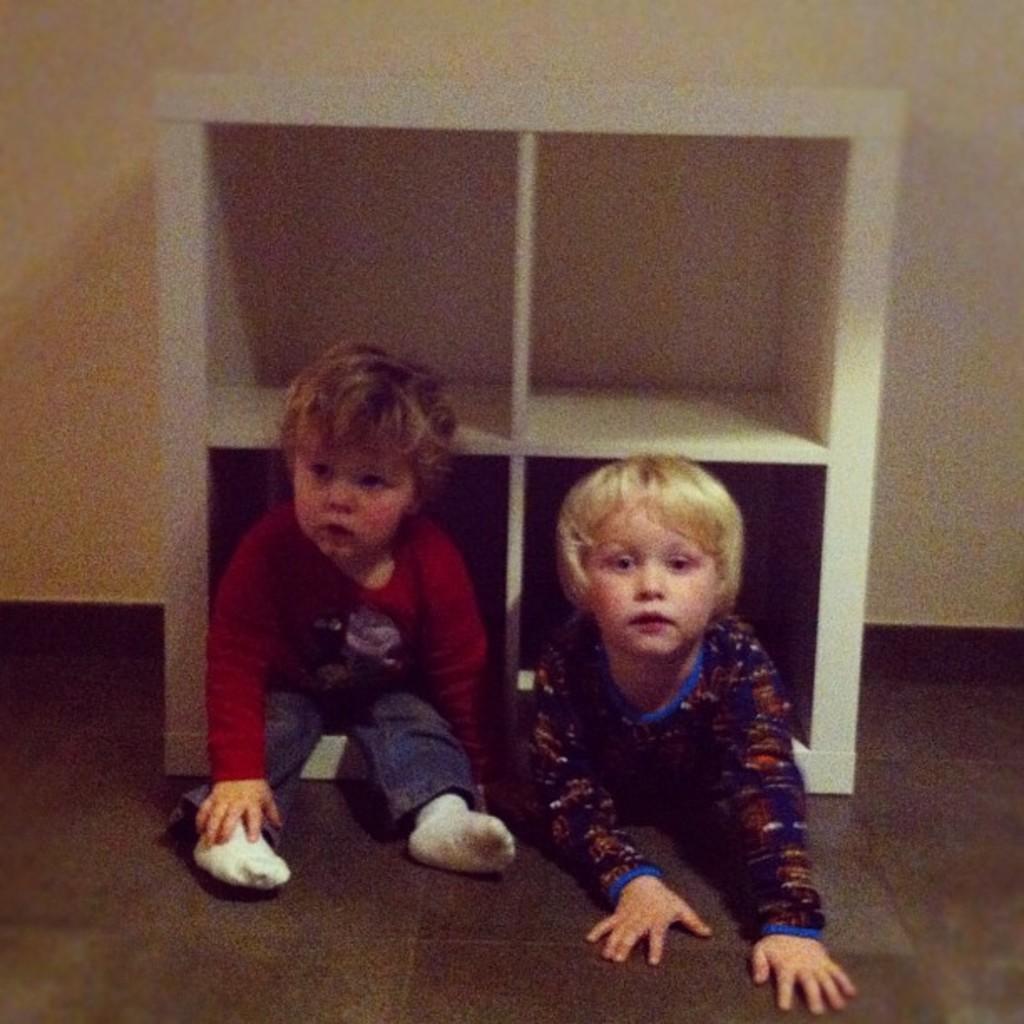Could you give a brief overview of what you see in this image? Here in this picture we can see two children present on the floor and behind them we can see a wooden rack present. 